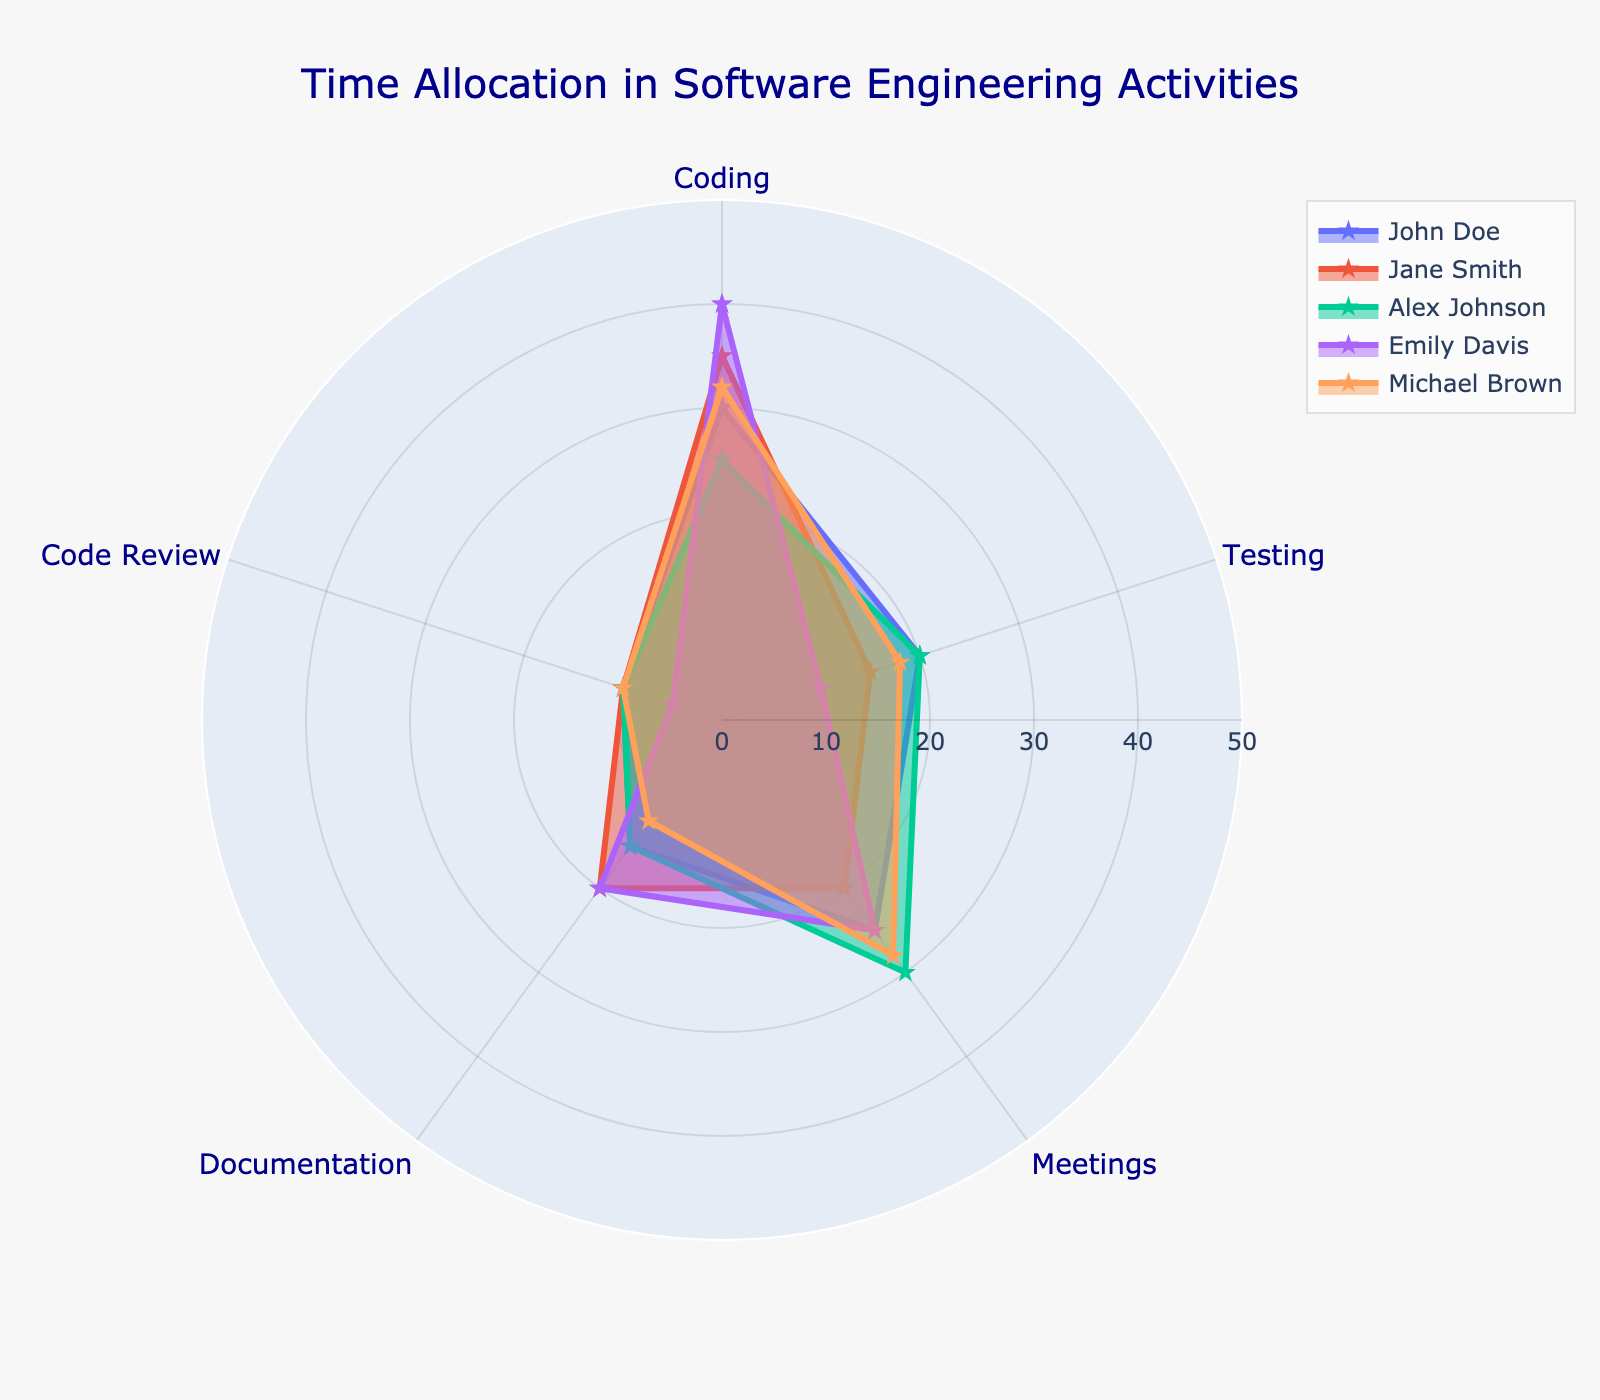What is the activity with the highest time allocation for Emily Davis? To determine which activity Emily Davis spends the most time on, look at the largest value associated with her in the radar chart. The highest value for Emily Davis is "Coding" with 40 units.
Answer: Coding How much time does Michael Brown allocate to Documentation? Check the value associated with Michael Brown and Documentation in the radar chart. It shows 12 units.
Answer: 12 Who spends the least amount of time on Code Review? Compare the values for Code Review across all individuals in the radar chart. Emily Davis has the least time allocated with 5 units.
Answer: Emily Davis What’s the average time spent on Testing by all engineers? Add the time spent on Testing by all engineers (20 + 15 + 20 + 10 + 18 = 83) and then divide by the number of engineers (5). The average is 83 / 5 = 16.6 units.
Answer: 16.6 Which engineer spends more time on Meetings than on Coding? Compare the time spent on Meetings and Coding for each engineer. Alex Johnson is the only one with higher time allocated to Meetings (30 units) compared to Coding (25 units).
Answer: Alex Johnson Who has the most balanced time allocation across all activities? A balanced allocation means a more uniform distribution of values across activities. Compare the radar charts for all engineers visually. Jane Smith has a relatively equal spread across activities.
Answer: Jane Smith What is the total time John Doe spends on all activities? Sum up the values associated with John Doe across all activities (30 + 20 + 25 + 15 + 10 = 100). John Doe's total time allocation is 100 units.
Answer: 100 Among all engineers, who allocates the most time to Testing? Compare the time allocated to Testing for each engineer. John Doe and Alex Johnson both allocate 20 units to Testing.
Answer: John Doe, Alex Johnson Who has the most time capacity left if a maximum of 50 units is allocated per activity? Compute the remaining capacity for each engineer per activity (assuming a 50-unit max), then sum the remaining capacities:
- John Doe: (50-30) + (50-20) + (50-25) + (50-15) + (50-10) = 20+30+25+35+40 = 150 units
- Jane Smith: (50-35) + (50-15) + (50-20) + (50-20) + (50-10) = 15+35+30+30+40 = 150 units
- Alex Johnson: (50-25) + (50-20) + (50-30) + (50-15) + (50-10) = 25+30+20+35+40 = 150 units
- Emily Davis: (50-40) + (50-10) + (50-25) + (50-20) + (50-5) = 10+40+25+30+45 = 150 units
- Michael Brown: (50-32) + (50-18) + (50-28) + (50-12) + (50-10) = 18+32+22+38+40 = 150 units
Each engineer has the same remaining capacity of 150 units.
Answer: All engineers What is the difference in time allocation for Documentation between Jane Smith and Michael Brown? Subtract the time allocated to Documentation by Michael Brown (12 units) from Jane Smith (20 units). The difference is 20 - 12 = 8 units.
Answer: 8 